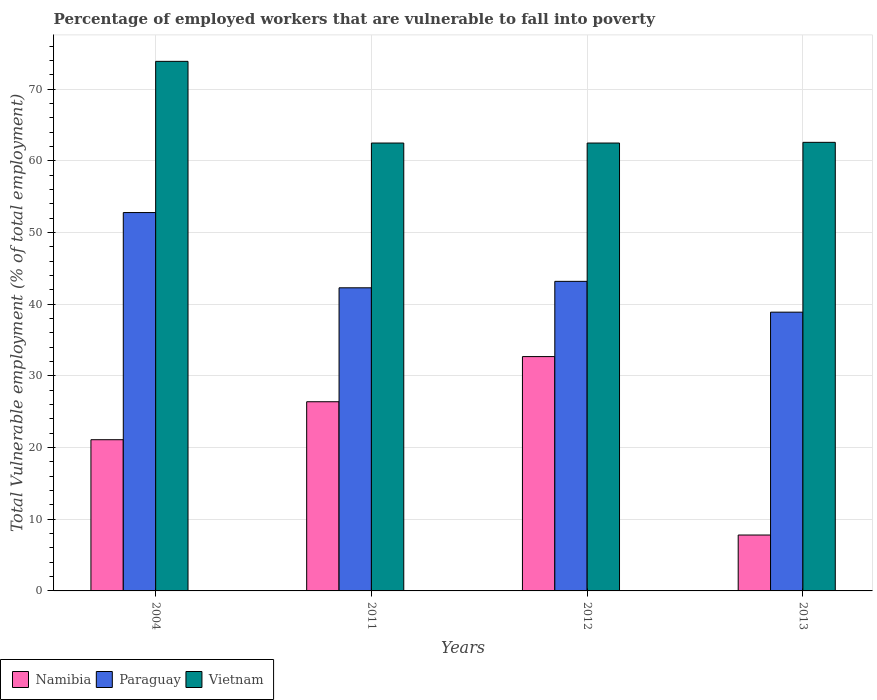How many different coloured bars are there?
Keep it short and to the point. 3. How many groups of bars are there?
Offer a very short reply. 4. How many bars are there on the 4th tick from the left?
Provide a succinct answer. 3. How many bars are there on the 3rd tick from the right?
Provide a succinct answer. 3. What is the percentage of employed workers who are vulnerable to fall into poverty in Vietnam in 2011?
Offer a terse response. 62.5. Across all years, what is the maximum percentage of employed workers who are vulnerable to fall into poverty in Vietnam?
Ensure brevity in your answer.  73.9. Across all years, what is the minimum percentage of employed workers who are vulnerable to fall into poverty in Paraguay?
Keep it short and to the point. 38.9. In which year was the percentage of employed workers who are vulnerable to fall into poverty in Namibia minimum?
Provide a short and direct response. 2013. What is the total percentage of employed workers who are vulnerable to fall into poverty in Paraguay in the graph?
Provide a succinct answer. 177.2. What is the difference between the percentage of employed workers who are vulnerable to fall into poverty in Namibia in 2004 and that in 2011?
Make the answer very short. -5.3. What is the difference between the percentage of employed workers who are vulnerable to fall into poverty in Paraguay in 2011 and the percentage of employed workers who are vulnerable to fall into poverty in Namibia in 2013?
Your answer should be very brief. 34.5. What is the average percentage of employed workers who are vulnerable to fall into poverty in Namibia per year?
Your answer should be very brief. 22. In the year 2011, what is the difference between the percentage of employed workers who are vulnerable to fall into poverty in Paraguay and percentage of employed workers who are vulnerable to fall into poverty in Namibia?
Offer a very short reply. 15.9. What is the ratio of the percentage of employed workers who are vulnerable to fall into poverty in Namibia in 2004 to that in 2013?
Your response must be concise. 2.71. Is the percentage of employed workers who are vulnerable to fall into poverty in Paraguay in 2004 less than that in 2011?
Ensure brevity in your answer.  No. Is the difference between the percentage of employed workers who are vulnerable to fall into poverty in Paraguay in 2012 and 2013 greater than the difference between the percentage of employed workers who are vulnerable to fall into poverty in Namibia in 2012 and 2013?
Your answer should be very brief. No. What is the difference between the highest and the second highest percentage of employed workers who are vulnerable to fall into poverty in Vietnam?
Ensure brevity in your answer.  11.3. What is the difference between the highest and the lowest percentage of employed workers who are vulnerable to fall into poverty in Namibia?
Ensure brevity in your answer.  24.9. In how many years, is the percentage of employed workers who are vulnerable to fall into poverty in Vietnam greater than the average percentage of employed workers who are vulnerable to fall into poverty in Vietnam taken over all years?
Offer a very short reply. 1. What does the 3rd bar from the left in 2004 represents?
Give a very brief answer. Vietnam. What does the 1st bar from the right in 2011 represents?
Your answer should be compact. Vietnam. Are all the bars in the graph horizontal?
Your answer should be compact. No. Does the graph contain grids?
Provide a succinct answer. Yes. How many legend labels are there?
Your answer should be compact. 3. How are the legend labels stacked?
Provide a short and direct response. Horizontal. What is the title of the graph?
Provide a short and direct response. Percentage of employed workers that are vulnerable to fall into poverty. What is the label or title of the Y-axis?
Your response must be concise. Total Vulnerable employment (% of total employment). What is the Total Vulnerable employment (% of total employment) of Namibia in 2004?
Give a very brief answer. 21.1. What is the Total Vulnerable employment (% of total employment) in Paraguay in 2004?
Make the answer very short. 52.8. What is the Total Vulnerable employment (% of total employment) in Vietnam in 2004?
Give a very brief answer. 73.9. What is the Total Vulnerable employment (% of total employment) in Namibia in 2011?
Ensure brevity in your answer.  26.4. What is the Total Vulnerable employment (% of total employment) of Paraguay in 2011?
Your answer should be compact. 42.3. What is the Total Vulnerable employment (% of total employment) in Vietnam in 2011?
Provide a succinct answer. 62.5. What is the Total Vulnerable employment (% of total employment) in Namibia in 2012?
Make the answer very short. 32.7. What is the Total Vulnerable employment (% of total employment) in Paraguay in 2012?
Offer a terse response. 43.2. What is the Total Vulnerable employment (% of total employment) in Vietnam in 2012?
Keep it short and to the point. 62.5. What is the Total Vulnerable employment (% of total employment) in Namibia in 2013?
Provide a short and direct response. 7.8. What is the Total Vulnerable employment (% of total employment) of Paraguay in 2013?
Offer a terse response. 38.9. What is the Total Vulnerable employment (% of total employment) in Vietnam in 2013?
Offer a terse response. 62.6. Across all years, what is the maximum Total Vulnerable employment (% of total employment) in Namibia?
Provide a short and direct response. 32.7. Across all years, what is the maximum Total Vulnerable employment (% of total employment) of Paraguay?
Keep it short and to the point. 52.8. Across all years, what is the maximum Total Vulnerable employment (% of total employment) of Vietnam?
Keep it short and to the point. 73.9. Across all years, what is the minimum Total Vulnerable employment (% of total employment) of Namibia?
Offer a terse response. 7.8. Across all years, what is the minimum Total Vulnerable employment (% of total employment) in Paraguay?
Provide a short and direct response. 38.9. Across all years, what is the minimum Total Vulnerable employment (% of total employment) of Vietnam?
Make the answer very short. 62.5. What is the total Total Vulnerable employment (% of total employment) of Namibia in the graph?
Offer a very short reply. 88. What is the total Total Vulnerable employment (% of total employment) of Paraguay in the graph?
Your answer should be compact. 177.2. What is the total Total Vulnerable employment (% of total employment) of Vietnam in the graph?
Make the answer very short. 261.5. What is the difference between the Total Vulnerable employment (% of total employment) in Paraguay in 2004 and that in 2011?
Your answer should be very brief. 10.5. What is the difference between the Total Vulnerable employment (% of total employment) in Vietnam in 2004 and that in 2011?
Make the answer very short. 11.4. What is the difference between the Total Vulnerable employment (% of total employment) of Namibia in 2004 and that in 2012?
Offer a very short reply. -11.6. What is the difference between the Total Vulnerable employment (% of total employment) in Paraguay in 2004 and that in 2012?
Provide a short and direct response. 9.6. What is the difference between the Total Vulnerable employment (% of total employment) of Vietnam in 2004 and that in 2013?
Your response must be concise. 11.3. What is the difference between the Total Vulnerable employment (% of total employment) in Paraguay in 2011 and that in 2012?
Make the answer very short. -0.9. What is the difference between the Total Vulnerable employment (% of total employment) in Vietnam in 2011 and that in 2012?
Ensure brevity in your answer.  0. What is the difference between the Total Vulnerable employment (% of total employment) in Vietnam in 2011 and that in 2013?
Your answer should be compact. -0.1. What is the difference between the Total Vulnerable employment (% of total employment) in Namibia in 2012 and that in 2013?
Your response must be concise. 24.9. What is the difference between the Total Vulnerable employment (% of total employment) in Paraguay in 2012 and that in 2013?
Your answer should be compact. 4.3. What is the difference between the Total Vulnerable employment (% of total employment) in Vietnam in 2012 and that in 2013?
Keep it short and to the point. -0.1. What is the difference between the Total Vulnerable employment (% of total employment) in Namibia in 2004 and the Total Vulnerable employment (% of total employment) in Paraguay in 2011?
Your response must be concise. -21.2. What is the difference between the Total Vulnerable employment (% of total employment) of Namibia in 2004 and the Total Vulnerable employment (% of total employment) of Vietnam in 2011?
Provide a short and direct response. -41.4. What is the difference between the Total Vulnerable employment (% of total employment) of Namibia in 2004 and the Total Vulnerable employment (% of total employment) of Paraguay in 2012?
Your answer should be very brief. -22.1. What is the difference between the Total Vulnerable employment (% of total employment) of Namibia in 2004 and the Total Vulnerable employment (% of total employment) of Vietnam in 2012?
Ensure brevity in your answer.  -41.4. What is the difference between the Total Vulnerable employment (% of total employment) in Namibia in 2004 and the Total Vulnerable employment (% of total employment) in Paraguay in 2013?
Your answer should be compact. -17.8. What is the difference between the Total Vulnerable employment (% of total employment) in Namibia in 2004 and the Total Vulnerable employment (% of total employment) in Vietnam in 2013?
Ensure brevity in your answer.  -41.5. What is the difference between the Total Vulnerable employment (% of total employment) in Namibia in 2011 and the Total Vulnerable employment (% of total employment) in Paraguay in 2012?
Offer a very short reply. -16.8. What is the difference between the Total Vulnerable employment (% of total employment) in Namibia in 2011 and the Total Vulnerable employment (% of total employment) in Vietnam in 2012?
Offer a terse response. -36.1. What is the difference between the Total Vulnerable employment (% of total employment) of Paraguay in 2011 and the Total Vulnerable employment (% of total employment) of Vietnam in 2012?
Offer a terse response. -20.2. What is the difference between the Total Vulnerable employment (% of total employment) of Namibia in 2011 and the Total Vulnerable employment (% of total employment) of Paraguay in 2013?
Your answer should be very brief. -12.5. What is the difference between the Total Vulnerable employment (% of total employment) in Namibia in 2011 and the Total Vulnerable employment (% of total employment) in Vietnam in 2013?
Give a very brief answer. -36.2. What is the difference between the Total Vulnerable employment (% of total employment) in Paraguay in 2011 and the Total Vulnerable employment (% of total employment) in Vietnam in 2013?
Provide a short and direct response. -20.3. What is the difference between the Total Vulnerable employment (% of total employment) in Namibia in 2012 and the Total Vulnerable employment (% of total employment) in Paraguay in 2013?
Your answer should be very brief. -6.2. What is the difference between the Total Vulnerable employment (% of total employment) of Namibia in 2012 and the Total Vulnerable employment (% of total employment) of Vietnam in 2013?
Keep it short and to the point. -29.9. What is the difference between the Total Vulnerable employment (% of total employment) of Paraguay in 2012 and the Total Vulnerable employment (% of total employment) of Vietnam in 2013?
Offer a very short reply. -19.4. What is the average Total Vulnerable employment (% of total employment) in Namibia per year?
Give a very brief answer. 22. What is the average Total Vulnerable employment (% of total employment) of Paraguay per year?
Keep it short and to the point. 44.3. What is the average Total Vulnerable employment (% of total employment) in Vietnam per year?
Provide a succinct answer. 65.38. In the year 2004, what is the difference between the Total Vulnerable employment (% of total employment) of Namibia and Total Vulnerable employment (% of total employment) of Paraguay?
Keep it short and to the point. -31.7. In the year 2004, what is the difference between the Total Vulnerable employment (% of total employment) of Namibia and Total Vulnerable employment (% of total employment) of Vietnam?
Offer a very short reply. -52.8. In the year 2004, what is the difference between the Total Vulnerable employment (% of total employment) in Paraguay and Total Vulnerable employment (% of total employment) in Vietnam?
Offer a terse response. -21.1. In the year 2011, what is the difference between the Total Vulnerable employment (% of total employment) of Namibia and Total Vulnerable employment (% of total employment) of Paraguay?
Offer a terse response. -15.9. In the year 2011, what is the difference between the Total Vulnerable employment (% of total employment) in Namibia and Total Vulnerable employment (% of total employment) in Vietnam?
Provide a succinct answer. -36.1. In the year 2011, what is the difference between the Total Vulnerable employment (% of total employment) in Paraguay and Total Vulnerable employment (% of total employment) in Vietnam?
Your answer should be very brief. -20.2. In the year 2012, what is the difference between the Total Vulnerable employment (% of total employment) of Namibia and Total Vulnerable employment (% of total employment) of Paraguay?
Offer a very short reply. -10.5. In the year 2012, what is the difference between the Total Vulnerable employment (% of total employment) of Namibia and Total Vulnerable employment (% of total employment) of Vietnam?
Ensure brevity in your answer.  -29.8. In the year 2012, what is the difference between the Total Vulnerable employment (% of total employment) in Paraguay and Total Vulnerable employment (% of total employment) in Vietnam?
Offer a terse response. -19.3. In the year 2013, what is the difference between the Total Vulnerable employment (% of total employment) in Namibia and Total Vulnerable employment (% of total employment) in Paraguay?
Offer a terse response. -31.1. In the year 2013, what is the difference between the Total Vulnerable employment (% of total employment) of Namibia and Total Vulnerable employment (% of total employment) of Vietnam?
Give a very brief answer. -54.8. In the year 2013, what is the difference between the Total Vulnerable employment (% of total employment) in Paraguay and Total Vulnerable employment (% of total employment) in Vietnam?
Your answer should be very brief. -23.7. What is the ratio of the Total Vulnerable employment (% of total employment) of Namibia in 2004 to that in 2011?
Provide a succinct answer. 0.8. What is the ratio of the Total Vulnerable employment (% of total employment) in Paraguay in 2004 to that in 2011?
Make the answer very short. 1.25. What is the ratio of the Total Vulnerable employment (% of total employment) in Vietnam in 2004 to that in 2011?
Your answer should be compact. 1.18. What is the ratio of the Total Vulnerable employment (% of total employment) of Namibia in 2004 to that in 2012?
Your answer should be very brief. 0.65. What is the ratio of the Total Vulnerable employment (% of total employment) in Paraguay in 2004 to that in 2012?
Your answer should be compact. 1.22. What is the ratio of the Total Vulnerable employment (% of total employment) in Vietnam in 2004 to that in 2012?
Keep it short and to the point. 1.18. What is the ratio of the Total Vulnerable employment (% of total employment) of Namibia in 2004 to that in 2013?
Give a very brief answer. 2.71. What is the ratio of the Total Vulnerable employment (% of total employment) in Paraguay in 2004 to that in 2013?
Your answer should be very brief. 1.36. What is the ratio of the Total Vulnerable employment (% of total employment) of Vietnam in 2004 to that in 2013?
Ensure brevity in your answer.  1.18. What is the ratio of the Total Vulnerable employment (% of total employment) in Namibia in 2011 to that in 2012?
Ensure brevity in your answer.  0.81. What is the ratio of the Total Vulnerable employment (% of total employment) of Paraguay in 2011 to that in 2012?
Your answer should be very brief. 0.98. What is the ratio of the Total Vulnerable employment (% of total employment) of Vietnam in 2011 to that in 2012?
Your answer should be compact. 1. What is the ratio of the Total Vulnerable employment (% of total employment) in Namibia in 2011 to that in 2013?
Provide a short and direct response. 3.38. What is the ratio of the Total Vulnerable employment (% of total employment) in Paraguay in 2011 to that in 2013?
Your answer should be very brief. 1.09. What is the ratio of the Total Vulnerable employment (% of total employment) in Vietnam in 2011 to that in 2013?
Make the answer very short. 1. What is the ratio of the Total Vulnerable employment (% of total employment) of Namibia in 2012 to that in 2013?
Give a very brief answer. 4.19. What is the ratio of the Total Vulnerable employment (% of total employment) of Paraguay in 2012 to that in 2013?
Your answer should be compact. 1.11. What is the ratio of the Total Vulnerable employment (% of total employment) in Vietnam in 2012 to that in 2013?
Offer a very short reply. 1. What is the difference between the highest and the second highest Total Vulnerable employment (% of total employment) of Paraguay?
Provide a succinct answer. 9.6. What is the difference between the highest and the lowest Total Vulnerable employment (% of total employment) in Namibia?
Your answer should be compact. 24.9. What is the difference between the highest and the lowest Total Vulnerable employment (% of total employment) in Paraguay?
Offer a terse response. 13.9. 